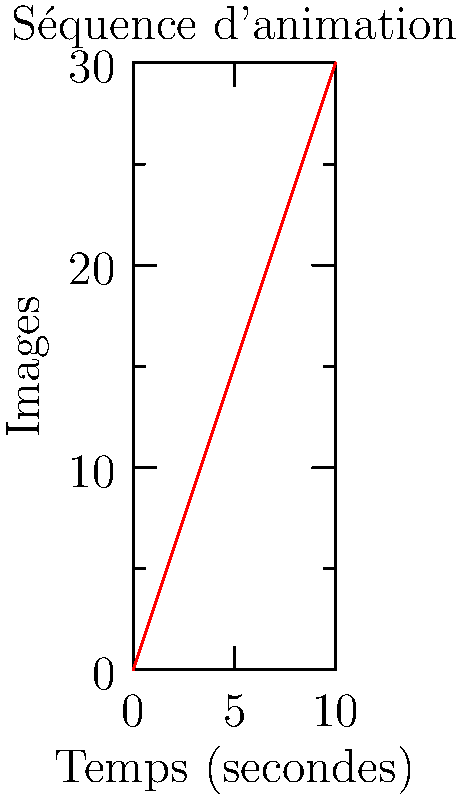Dans cette séquence d'animation avant-gardiste, le graphique représente la relation entre le temps et le nombre d'images. Quelle est la cadence d'images (en images par seconde) de cette séquence ? Exprimez votre réponse en utilisant la notation cinématographique standard. Pour déterminer la cadence d'images, nous devons suivre ces étapes :

1) Observons le graphique : l'axe x représente le temps en secondes, et l'axe y représente le nombre d'images.

2) Identifions deux points sur la ligne pour calculer la pente :
   - À 0 seconde, nous avons 0 image
   - À 10 secondes, nous avons 30 images

3) Calculons la pente, qui représente le nombre d'images par seconde :
   $$ \text{Pente} = \frac{\text{Différence en y}}{\text{Différence en x}} = \frac{30 - 0}{10 - 0} = \frac{30}{10} = 3 $$

4) La pente de 3 signifie que nous avons 3 images par seconde.

5) Dans la notation cinématographique standard, nous exprimons cela comme "3 fps" (frames per second).

Cette cadence d'images relativement basse de 3 fps est intéressante d'un point de vue artistique. Elle pourrait créer un effet de mouvement saccadé, rappelant peut-être les premières animations ou offrant une esthétique unique et expérimentale.
Answer: 3 fps 